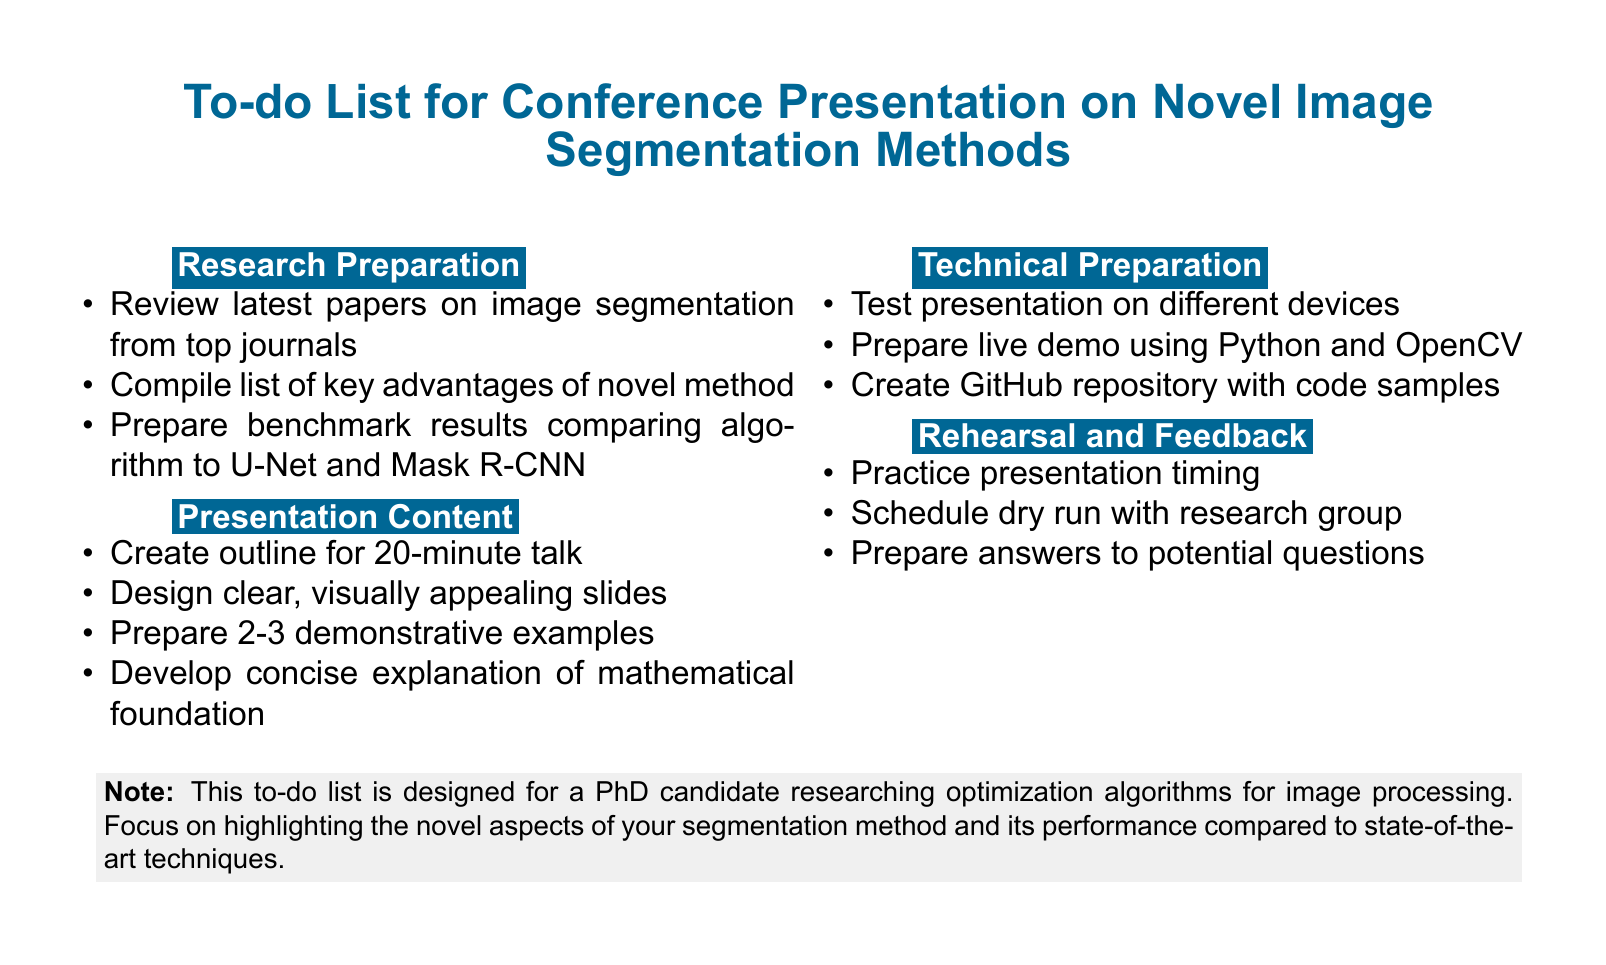What is the title of the document? The title is stated at the top of the document, summarizing its main focus.
Answer: To-do List for Conference Presentation on Novel Image Segmentation Methods How many sections are in the to-do list? The document lists four distinct sections, each pertaining to different preparation aspects.
Answer: 4 What are the main techniques compared in the benchmark results? The document specifies two specific algorithms that the novel method is being compared to in the benchmark results.
Answer: U-Net and Mask R-CNN What should be prepared alongside the live demo? The document outlines the importance of creating a supporting online resource that showcases additional information.
Answer: GitHub repository What is the allocated time for the presentation? The document clearly states the time limit for the conference presentation to ensure effective planning.
Answer: 20 minutes What is the purpose of scheduling a dry run? This is to incorporate feedback and improve the presentation, based on collaboration with peers.
Answer: Incorporate feedback Which software can be used for designing slides? The document suggests options for creating visually appealing presentation materials, explicitly mentioning one of them.
Answer: LaTeX Beamer or PowerPoint What fundamental aspect of the optimization approach needs explanation? The document emphasizes the need to clearly communicate a specific theoretical underlining of the methodology used.
Answer: Mathematical foundation What is one example of a demonstrative tool mentioned for live demos? The document points out a programming language and library that will be utilized for the demonstration part.
Answer: Python and OpenCV 